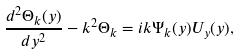<formula> <loc_0><loc_0><loc_500><loc_500>\frac { d ^ { 2 } \Theta _ { k } ( y ) } { d y ^ { 2 } } - k ^ { 2 } \Theta _ { k } = i k \Psi _ { k } ( y ) U _ { y } ( y ) ,</formula> 